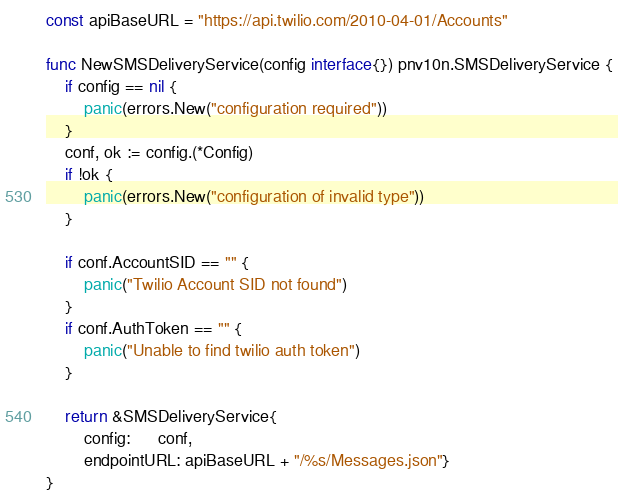<code> <loc_0><loc_0><loc_500><loc_500><_Go_>
const apiBaseURL = "https://api.twilio.com/2010-04-01/Accounts"

func NewSMSDeliveryService(config interface{}) pnv10n.SMSDeliveryService {
	if config == nil {
		panic(errors.New("configuration required"))
	}
	conf, ok := config.(*Config)
	if !ok {
		panic(errors.New("configuration of invalid type"))
	}

	if conf.AccountSID == "" {
		panic("Twilio Account SID not found")
	}
	if conf.AuthToken == "" {
		panic("Unable to find twilio auth token")
	}

	return &SMSDeliveryService{
		config:      conf,
		endpointURL: apiBaseURL + "/%s/Messages.json"}
}
</code> 